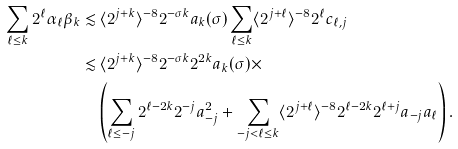Convert formula to latex. <formula><loc_0><loc_0><loc_500><loc_500>\sum _ { \ell \leq k } 2 ^ { \ell } \alpha _ { \ell } \beta _ { k } \lesssim & \, \langle 2 ^ { j + k } \rangle ^ { - 8 } 2 ^ { - \sigma k } a _ { k } ( \sigma ) \sum _ { \ell \leq k } \langle 2 ^ { j + \ell } \rangle ^ { - 8 } 2 ^ { \ell } c _ { \ell , j } \\ \lesssim & \, \langle 2 ^ { j + k } \rangle ^ { - 8 } 2 ^ { - \sigma k } 2 ^ { 2 k } a _ { k } ( \sigma ) \times \\ & \left ( \sum _ { \ell \leq - j } 2 ^ { \ell - 2 k } 2 ^ { - j } a _ { - j } ^ { 2 } + \sum _ { - j < \ell \leq k } \langle 2 ^ { j + \ell } \rangle ^ { - 8 } 2 ^ { \ell - 2 k } 2 ^ { \ell + j } a _ { - j } a _ { \ell } \right ) .</formula> 